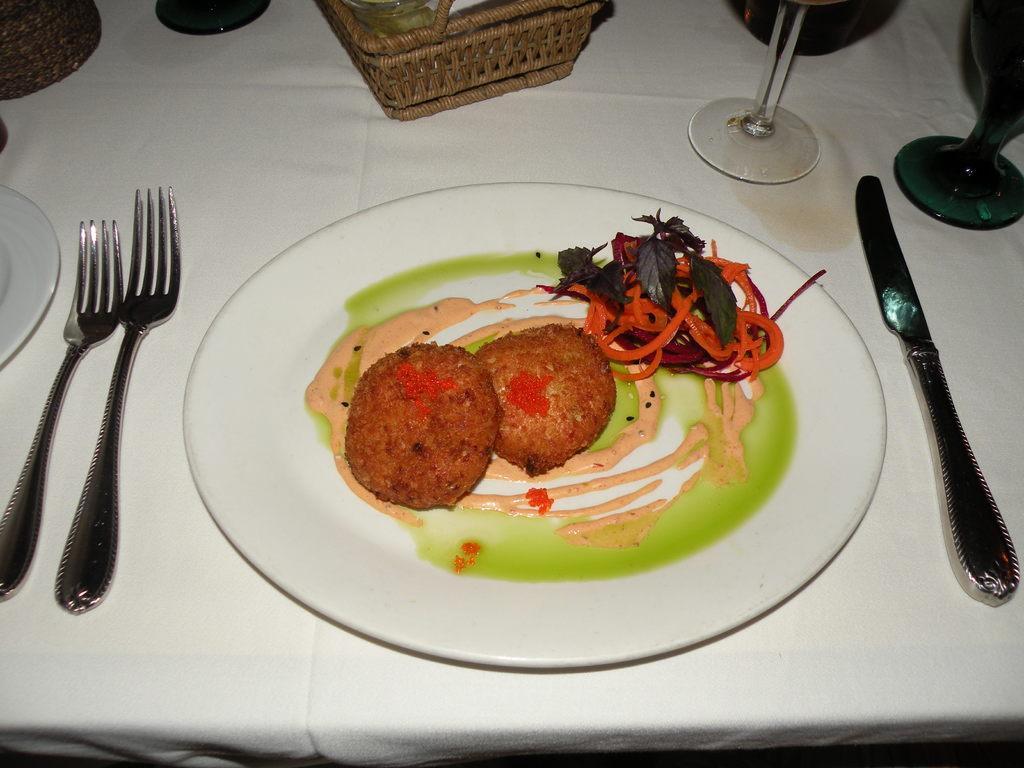Please provide a concise description of this image. In this picture I can see food in the plate and I can see couple of forks and a knife, I can see a basket and few glasses on the table. 